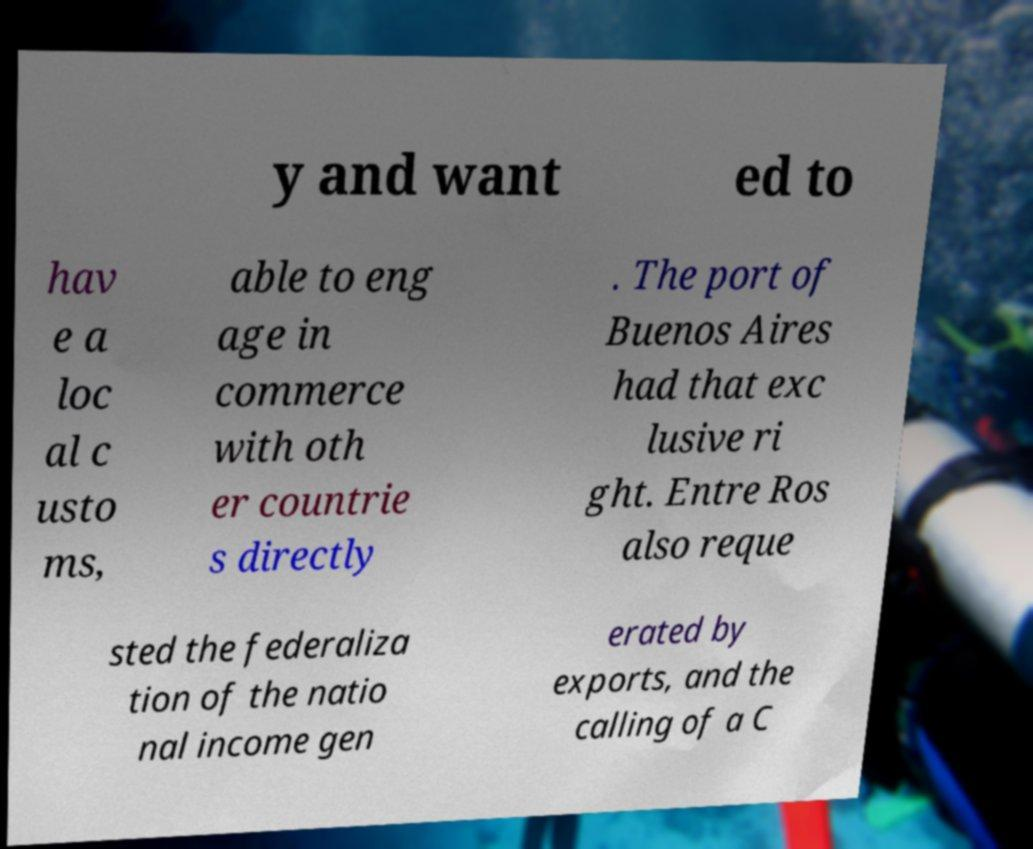Could you extract and type out the text from this image? y and want ed to hav e a loc al c usto ms, able to eng age in commerce with oth er countrie s directly . The port of Buenos Aires had that exc lusive ri ght. Entre Ros also reque sted the federaliza tion of the natio nal income gen erated by exports, and the calling of a C 